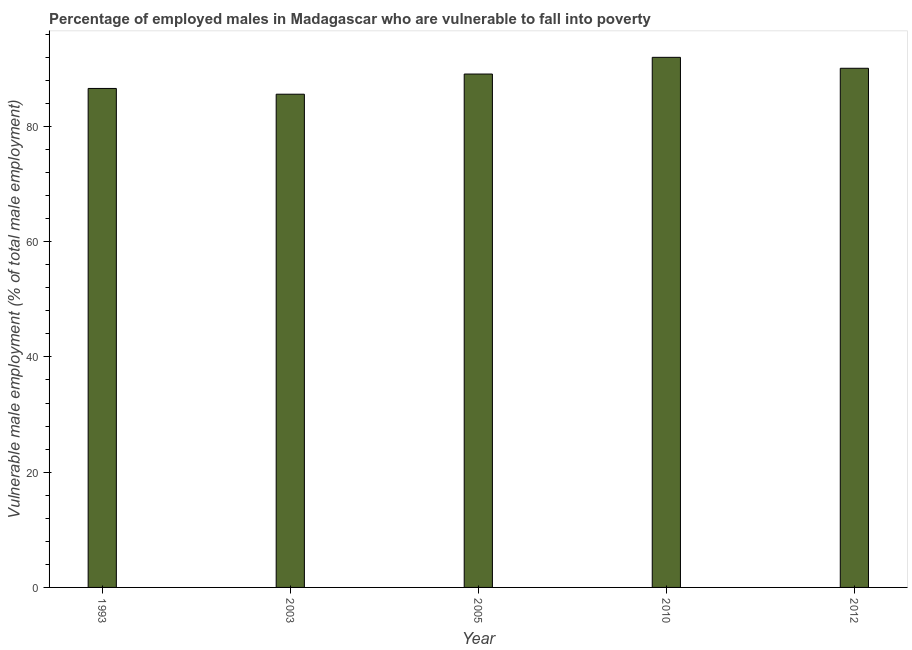What is the title of the graph?
Your answer should be very brief. Percentage of employed males in Madagascar who are vulnerable to fall into poverty. What is the label or title of the Y-axis?
Offer a terse response. Vulnerable male employment (% of total male employment). What is the percentage of employed males who are vulnerable to fall into poverty in 2010?
Make the answer very short. 92. Across all years, what is the maximum percentage of employed males who are vulnerable to fall into poverty?
Give a very brief answer. 92. Across all years, what is the minimum percentage of employed males who are vulnerable to fall into poverty?
Ensure brevity in your answer.  85.6. In which year was the percentage of employed males who are vulnerable to fall into poverty maximum?
Give a very brief answer. 2010. In which year was the percentage of employed males who are vulnerable to fall into poverty minimum?
Provide a short and direct response. 2003. What is the sum of the percentage of employed males who are vulnerable to fall into poverty?
Keep it short and to the point. 443.4. What is the difference between the percentage of employed males who are vulnerable to fall into poverty in 2010 and 2012?
Provide a short and direct response. 1.9. What is the average percentage of employed males who are vulnerable to fall into poverty per year?
Give a very brief answer. 88.68. What is the median percentage of employed males who are vulnerable to fall into poverty?
Your answer should be very brief. 89.1. In how many years, is the percentage of employed males who are vulnerable to fall into poverty greater than 4 %?
Offer a terse response. 5. Is the difference between the percentage of employed males who are vulnerable to fall into poverty in 2003 and 2005 greater than the difference between any two years?
Make the answer very short. No. What is the difference between the highest and the second highest percentage of employed males who are vulnerable to fall into poverty?
Your answer should be very brief. 1.9. Is the sum of the percentage of employed males who are vulnerable to fall into poverty in 1993 and 2005 greater than the maximum percentage of employed males who are vulnerable to fall into poverty across all years?
Your response must be concise. Yes. In how many years, is the percentage of employed males who are vulnerable to fall into poverty greater than the average percentage of employed males who are vulnerable to fall into poverty taken over all years?
Offer a terse response. 3. What is the difference between two consecutive major ticks on the Y-axis?
Offer a very short reply. 20. Are the values on the major ticks of Y-axis written in scientific E-notation?
Give a very brief answer. No. What is the Vulnerable male employment (% of total male employment) of 1993?
Make the answer very short. 86.6. What is the Vulnerable male employment (% of total male employment) of 2003?
Ensure brevity in your answer.  85.6. What is the Vulnerable male employment (% of total male employment) in 2005?
Your answer should be very brief. 89.1. What is the Vulnerable male employment (% of total male employment) of 2010?
Provide a succinct answer. 92. What is the Vulnerable male employment (% of total male employment) in 2012?
Your answer should be very brief. 90.1. What is the difference between the Vulnerable male employment (% of total male employment) in 1993 and 2010?
Give a very brief answer. -5.4. What is the difference between the Vulnerable male employment (% of total male employment) in 1993 and 2012?
Provide a short and direct response. -3.5. What is the difference between the Vulnerable male employment (% of total male employment) in 2003 and 2005?
Make the answer very short. -3.5. What is the difference between the Vulnerable male employment (% of total male employment) in 2003 and 2010?
Make the answer very short. -6.4. What is the difference between the Vulnerable male employment (% of total male employment) in 2003 and 2012?
Your answer should be compact. -4.5. What is the difference between the Vulnerable male employment (% of total male employment) in 2005 and 2010?
Ensure brevity in your answer.  -2.9. What is the difference between the Vulnerable male employment (% of total male employment) in 2005 and 2012?
Ensure brevity in your answer.  -1. What is the ratio of the Vulnerable male employment (% of total male employment) in 1993 to that in 2010?
Your response must be concise. 0.94. What is the ratio of the Vulnerable male employment (% of total male employment) in 2003 to that in 2005?
Provide a succinct answer. 0.96. What is the ratio of the Vulnerable male employment (% of total male employment) in 2003 to that in 2012?
Your response must be concise. 0.95. What is the ratio of the Vulnerable male employment (% of total male employment) in 2005 to that in 2012?
Provide a short and direct response. 0.99. What is the ratio of the Vulnerable male employment (% of total male employment) in 2010 to that in 2012?
Provide a succinct answer. 1.02. 